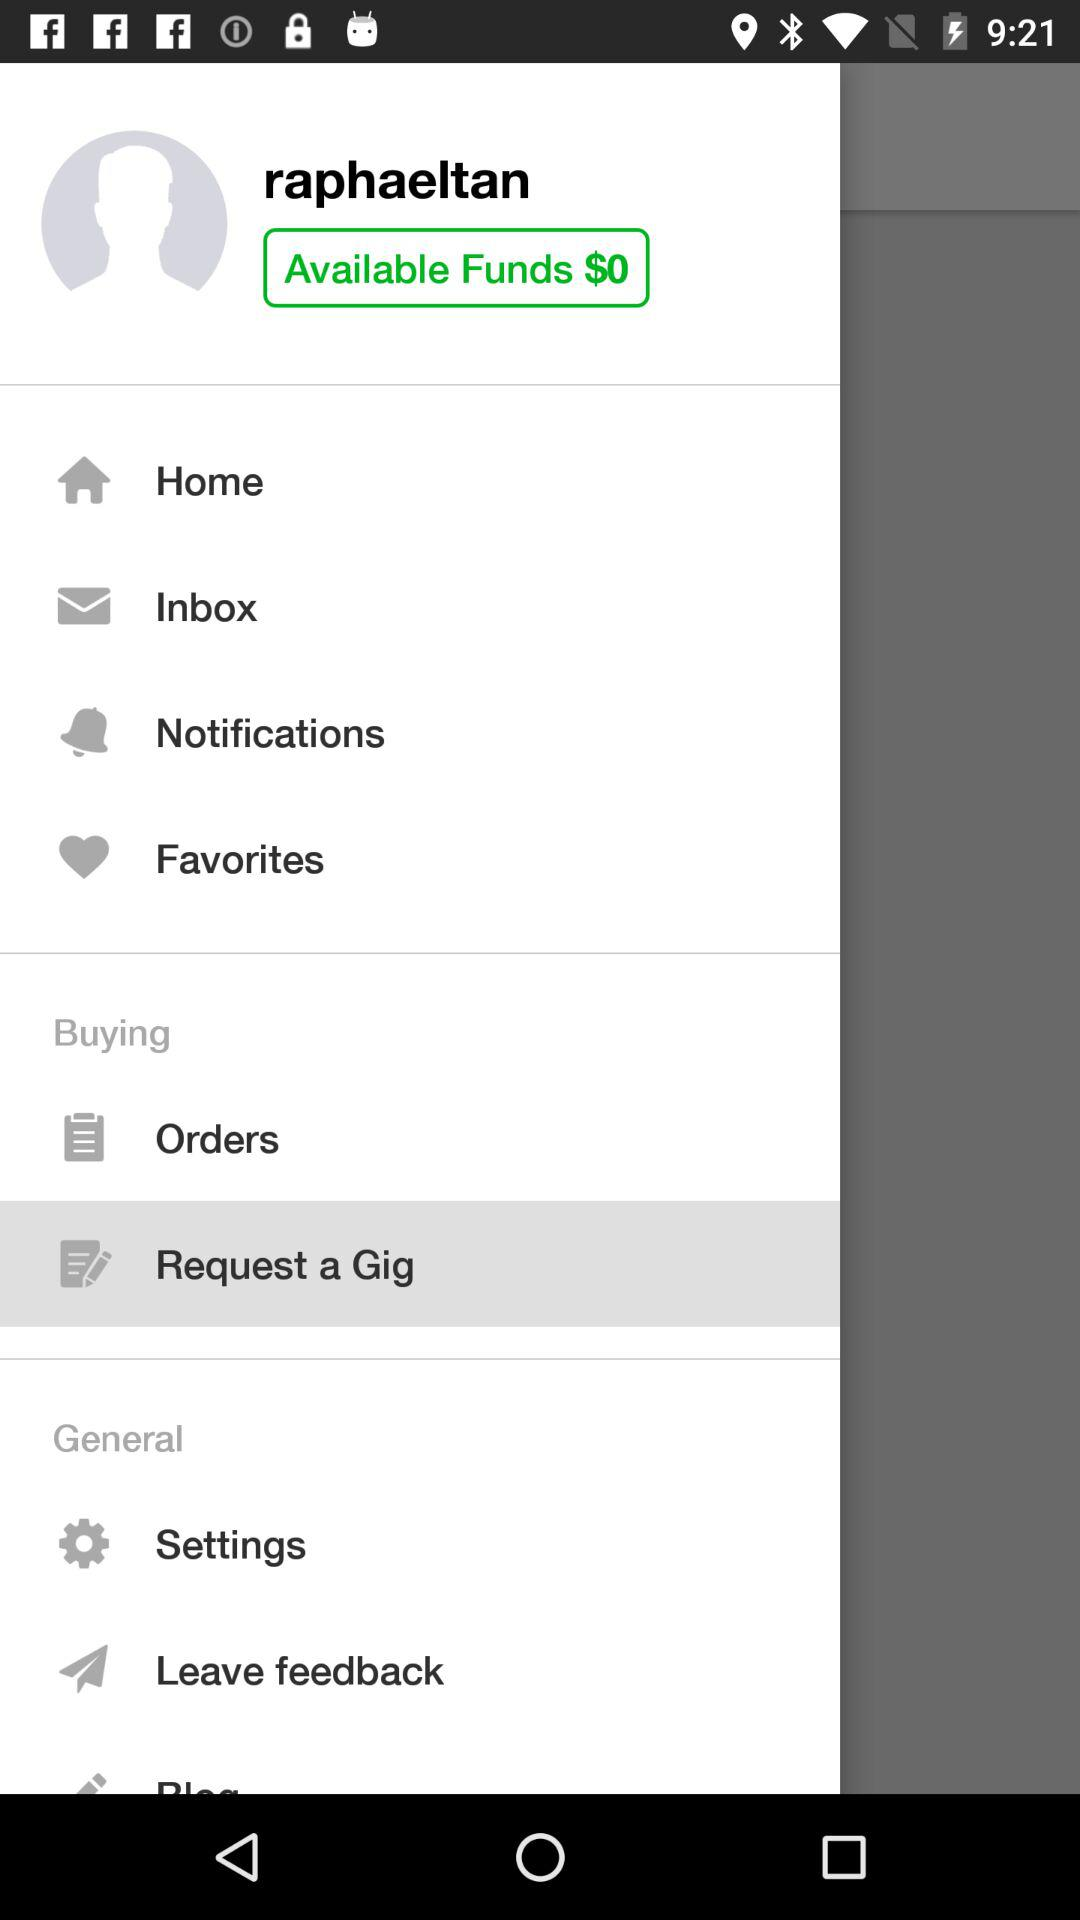What is the username? The username is "raphaeltan". 